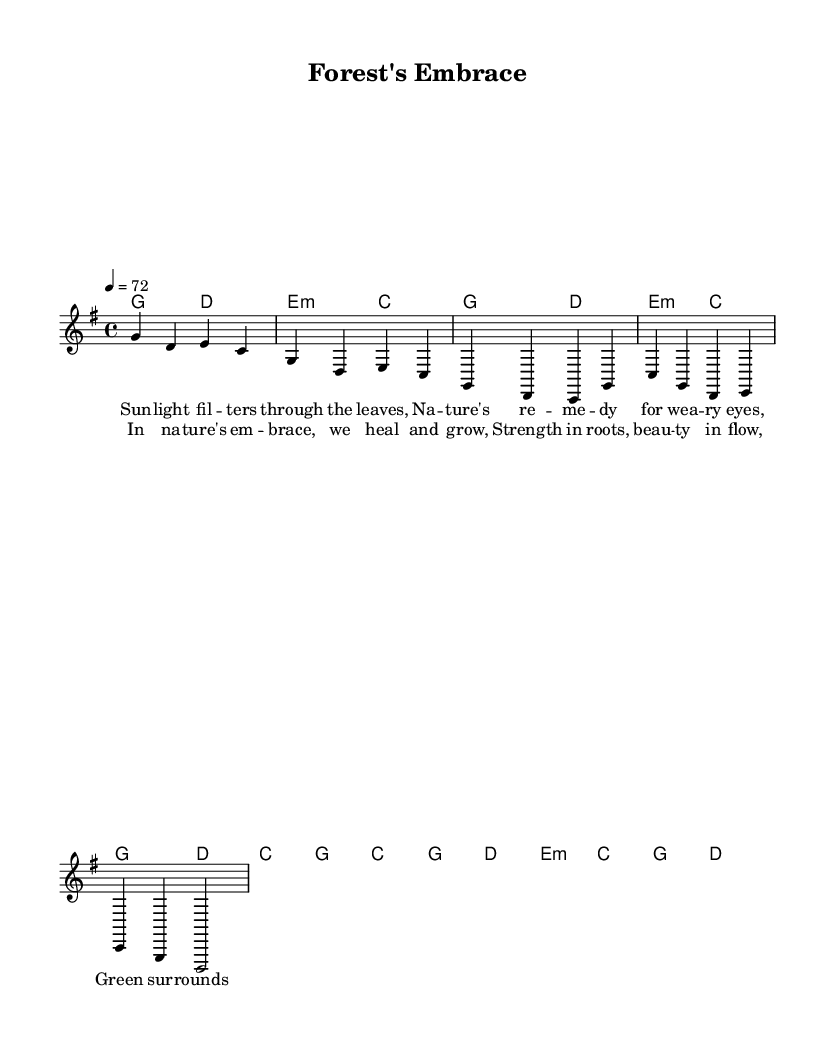What is the key signature of this music? The key signature indicates that the music is in G major, which has one sharp (F#) as indicated in the global section of the code.
Answer: G major What is the time signature of this piece? The time signature is found in the global section of the code, which is marked as 4/4. This means there are four beats in each measure.
Answer: 4/4 What is the tempo marking for this composition? The tempo marking is stated in the global section of the code, where it is noted as 4 = 72, indicating that there are 72 quarter note beats per minute.
Answer: 72 How many measures are in the verse? The verse is explicitly represented in the melody section, with a count of four measures that repeat throughout the lyrics. Counting the measures shows that there are four measures in total.
Answer: 4 What is the primary theme of the lyrics in the chorus? The chorus lyrics emphasize healing and growth through nature, as seen in the words that describe strengthening roots and beauty in flow, which encapsulates the overall theme of the song.
Answer: Healing and growth What is the chord that accompanies the first chord of the chorus? The first chord of the chorus is C major, as indicated in the harmonies section, aligning with the beginning of the chorus.
Answer: C major What is the correlation between the lyrics and the musical structure in the verse? The lyrics in the verse correspond consistently with the melody and harmonies, featuring a four-bar structure that creates a rhythmic and melodic complement to the text. This structured alignment enhances the thematic connection between nature and well-being.
Answer: Consistent alignment 